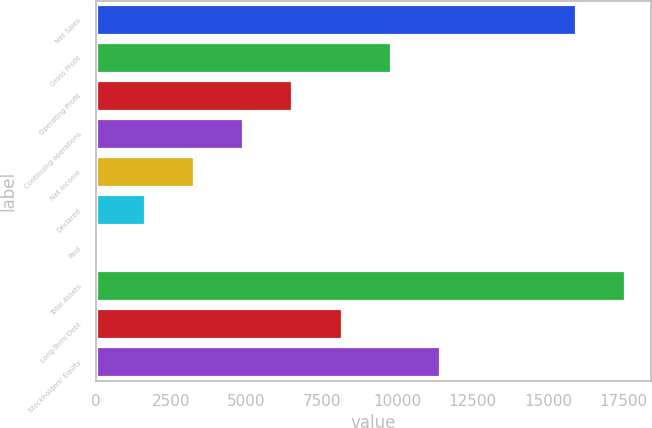<chart> <loc_0><loc_0><loc_500><loc_500><bar_chart><fcel>Net Sales<fcel>Gross Profit<fcel>Operating Profit<fcel>Continuing operations<fcel>Net income<fcel>Declared<fcel>Paid<fcel>Total Assets<fcel>Long-Term Debt<fcel>Stockholders' Equity<nl><fcel>15902.6<fcel>9782.65<fcel>6522.35<fcel>4892.2<fcel>3262.05<fcel>1631.9<fcel>1.75<fcel>17532.7<fcel>8152.5<fcel>11412.8<nl></chart> 